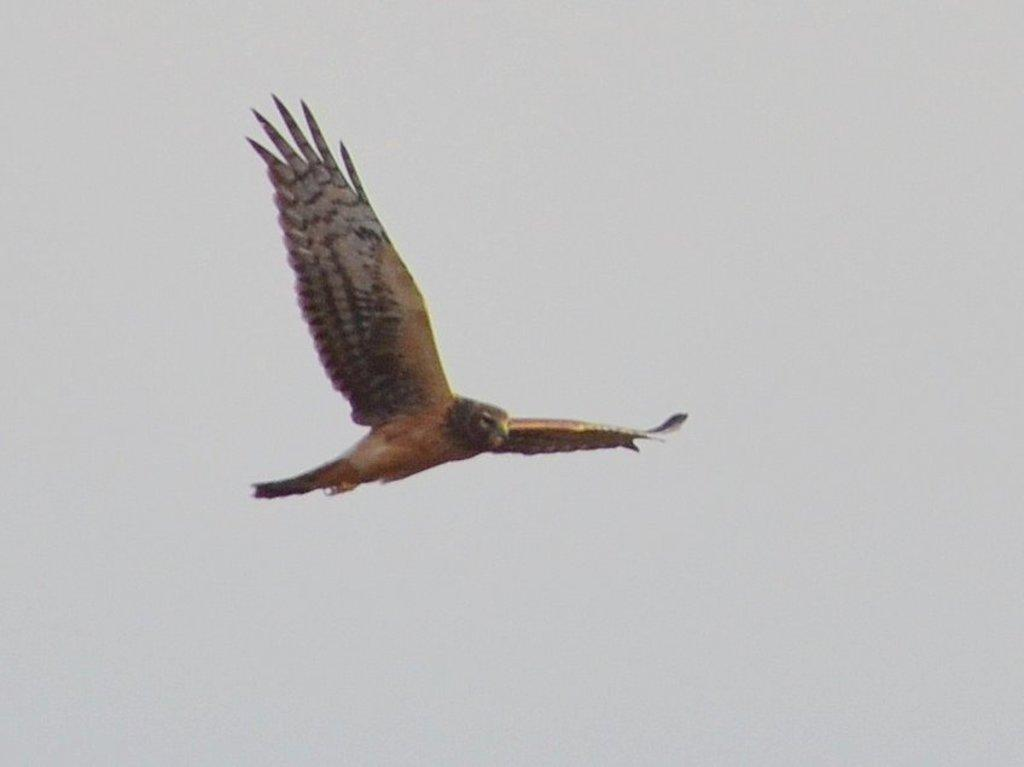What animal is the main subject of the image? There is an eagle in the image. What is the eagle doing in the image? The eagle is flying. What can be seen in the background of the image? The sky is visible in the background of the image. What type of lawyer is the eagle representing in the image? There is no lawyer or legal representation present in the image; it features an eagle flying in the sky. 